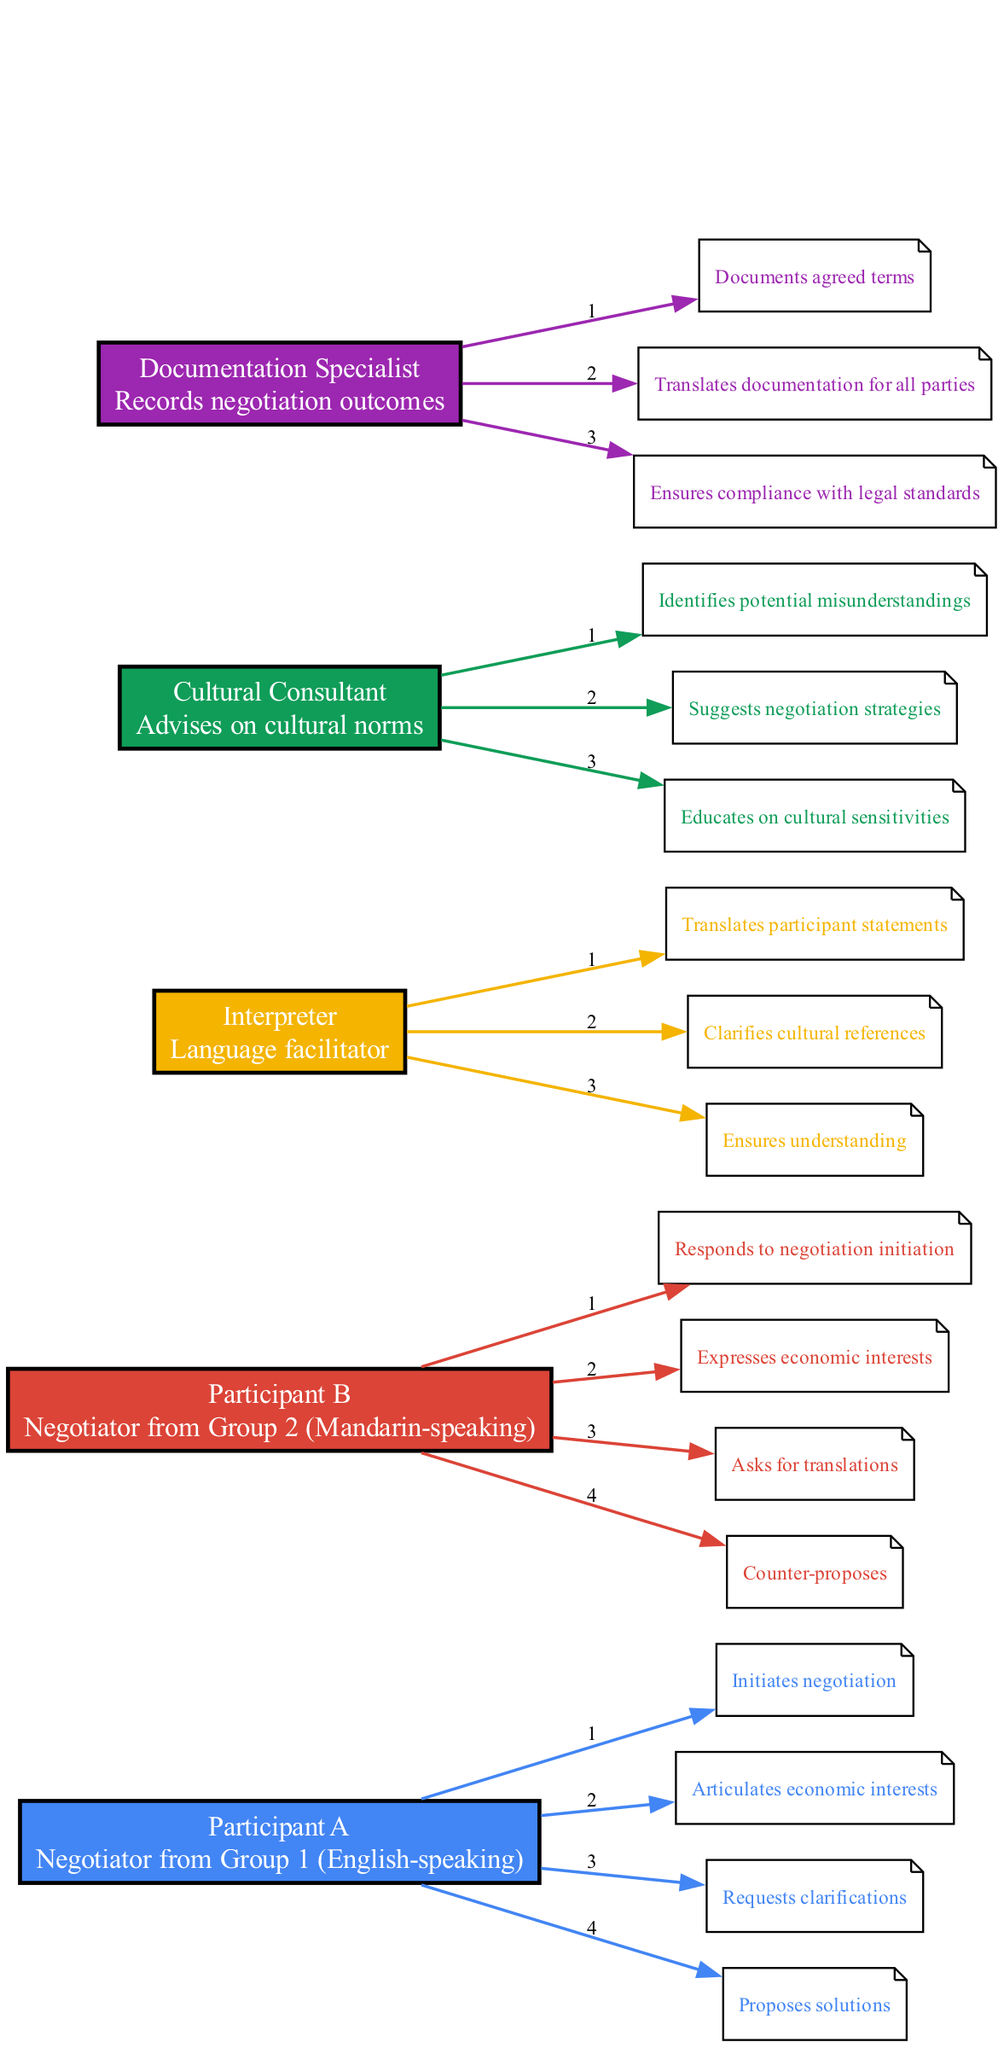What role does the Interpreter play in the negotiation? The Interpreter is responsible for translating participant statements, clarifying cultural references, and ensuring understanding between the participants. These actions indicate that the Interpreter acts as a facilitator between the English-speaking and Mandarin-speaking negotiators.
Answer: Language facilitator How many actions does Participant B have? By examining the sequence diagram for Participant B (Mandarin-speaking negotiator), we see that there are four distinct actions listed: responding to negotiation initiation, expressing economic interests, asking for translations, and counter-proposing. Therefore, the total count of actions is four.
Answer: Four Which participant initiates the negotiation? In the sequence diagram, the actions clearly indicate that Participant A (the English-speaking negotiator) is the one who initiates the negotiation. This is stated directly as the first action listed for Participant A.
Answer: Participant A What is the last action performed by Participant A? Looking at the actions listed for Participant A, the last action is proposing solutions. This is the final step in the sequence for that participant before moving on to other actions or participants.
Answer: Proposes solutions Who advises on cultural norms? The diagram specifies that the Cultural Consultant advises on cultural norms and also performs several relevant actions related to understanding and suggesting negotiation strategies. Therefore, the identification leads us directly to the Cultural Consultant.
Answer: Cultural Consultant What is the purpose of the Documentation Specialist's actions? The actions associated with the Documentation Specialist focus on recording negotiation outcomes, translating documentation for all parties, and ensuring compliance with legal standards. This highlights their role in ensuring that the results of negotiations are properly documented and communicated.
Answer: Records negotiation outcomes How do the roles of the Interpreter and Cultural Consultant differ? The Interpreter primarily translates languages and ensures understanding between the participants, while the Cultural Consultant focuses on identifying misunderstandings in cultural contexts and suggesting negotiation strategies. Thus, their roles complement each other but serve different functions within the negotiation.
Answer: Translator vs. advisor How many participants are involved in the negotiation? By counting the different participants listed in the diagram (Participant A, Participant B, Interpreter, Cultural Consultant, and Documentation Specialist), we find there are five distinct participants involved in the negotiation process.
Answer: Five What does Participant B ask for? The actions indicate that Participant B, the Mandarin-speaking negotiator, asks for translations as part of the negotiation process, illustrating the challenges due to language differences.
Answer: Asks for translations 